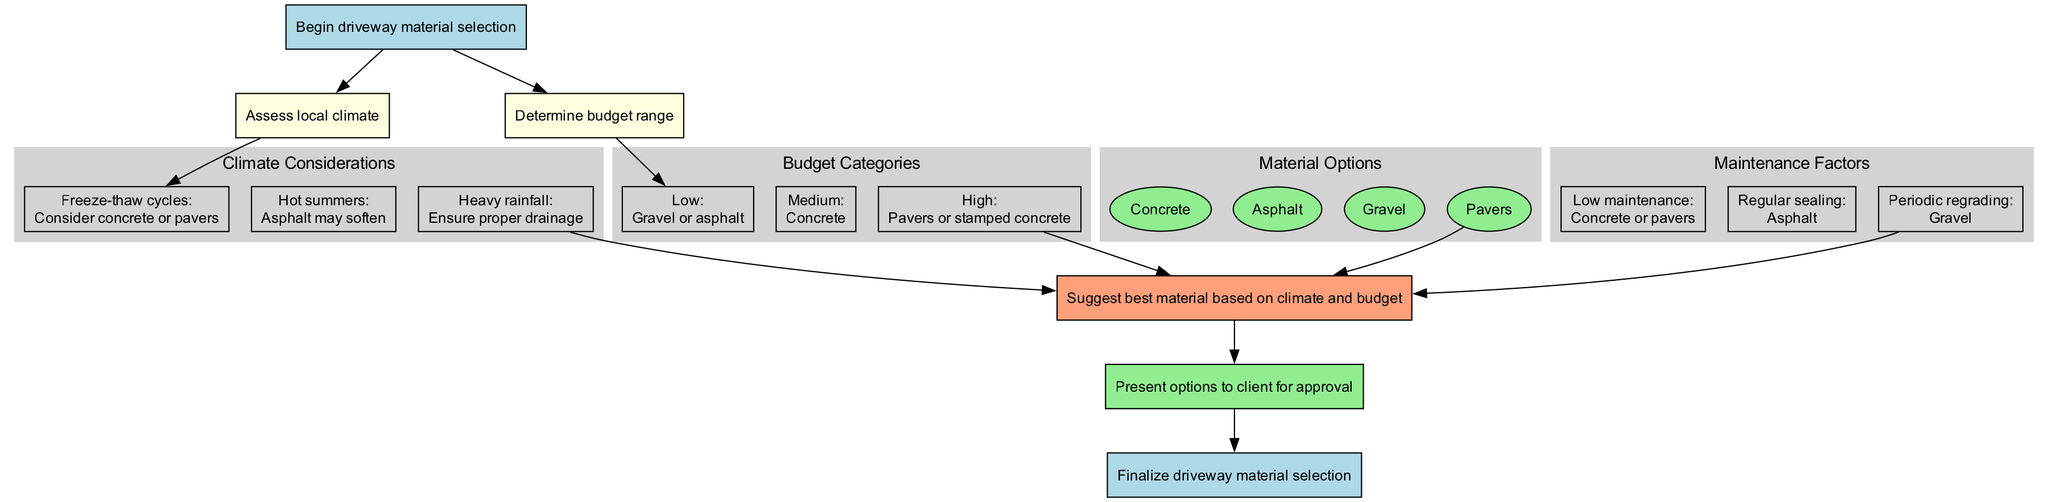What is the first step in the driveway material selection process? The first step in the process is represented by the start node. It is labeled "Begin driveway material selection" which serves as the entry point into the entire selection process.
Answer: Begin driveway material selection How many climate considerations are listed in the diagram? The box labeled "Climate Considerations" contains three considerations regarding freeze-thaw cycles, hot summers, and heavy rainfall. By counting these conditions, we find that there are three listed.
Answer: 3 What material is suggested for a low budget? In the budget category labeled "Low," the options given are "Gravel or asphalt." Therefore, the first material mentioned is sufficient to answer the question.
Answer: Gravel or asphalt Which material requires regular sealing? In the maintenance factors section, the factor labeled "Regular sealing" is associated with "Asphalt." This indicates that asphalt is the material requiring regular sealing.
Answer: Asphalt What is the final recommendation based on? The final recommendation considers inputs from climate considerations, budget categories, material options, and maintenance factors. Each of these aspects is node-connected to the recommendation node, indicating the need to evaluate all of them.
Answer: Climate and budget How many edges connect the climate considerations to the recommendation? Each climate condition connects to the recommendation node, leading to the conclusion that there are three edges from the climate considerations to the recommendation.
Answer: 3 What are the two types of maintenance mentioned? The maintenance factors present three categories, but only two directly mention materials: "Low maintenance" which refers to "Concrete or pavers" and "Regular sealing" pertaining to "Asphalt." The question asks for the two types that involve materials, so these two categories apply.
Answer: Concrete or pavers and Asphalt Which budget category suggests pavers? The budget category labeled "High" indicates "Pavers or stamped concrete" as the materials suitable for a high budget. Hence, pavers fall under this category.
Answer: High What is the last step in the driveway material selection process? The end of the process is marked by the node labeled "Finalize driveway material selection." This signifies that the process concludes with this step.
Answer: Finalize driveway material selection 